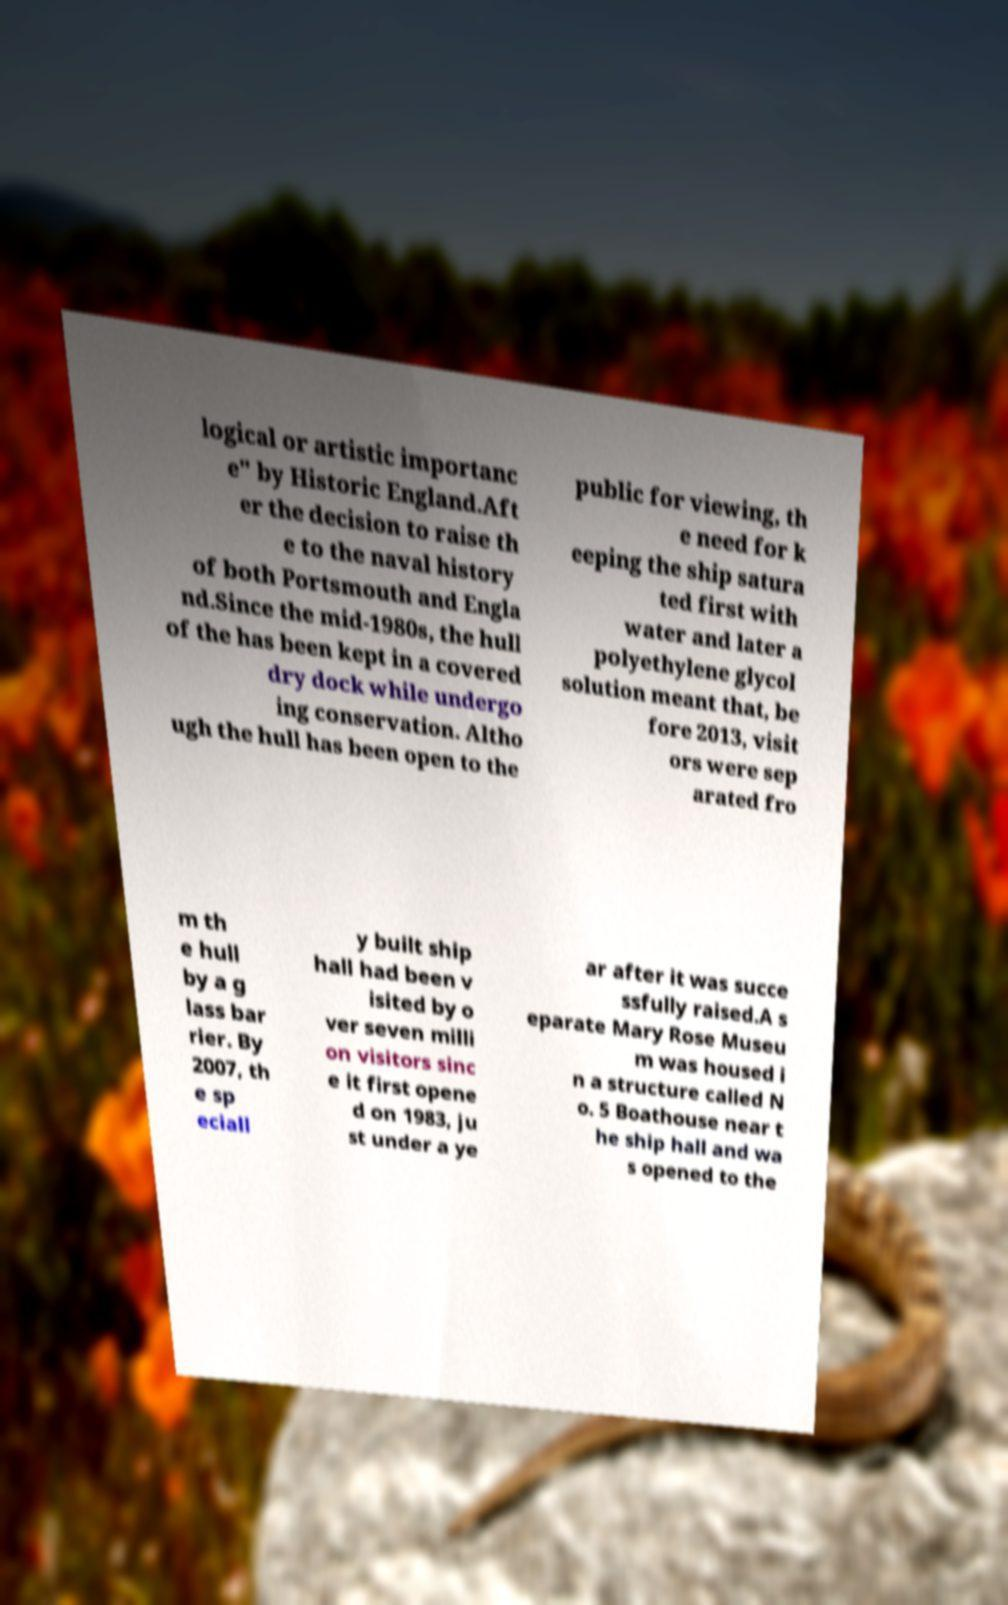Can you accurately transcribe the text from the provided image for me? logical or artistic importanc e" by Historic England.Aft er the decision to raise th e to the naval history of both Portsmouth and Engla nd.Since the mid-1980s, the hull of the has been kept in a covered dry dock while undergo ing conservation. Altho ugh the hull has been open to the public for viewing, th e need for k eeping the ship satura ted first with water and later a polyethylene glycol solution meant that, be fore 2013, visit ors were sep arated fro m th e hull by a g lass bar rier. By 2007, th e sp eciall y built ship hall had been v isited by o ver seven milli on visitors sinc e it first opene d on 1983, ju st under a ye ar after it was succe ssfully raised.A s eparate Mary Rose Museu m was housed i n a structure called N o. 5 Boathouse near t he ship hall and wa s opened to the 